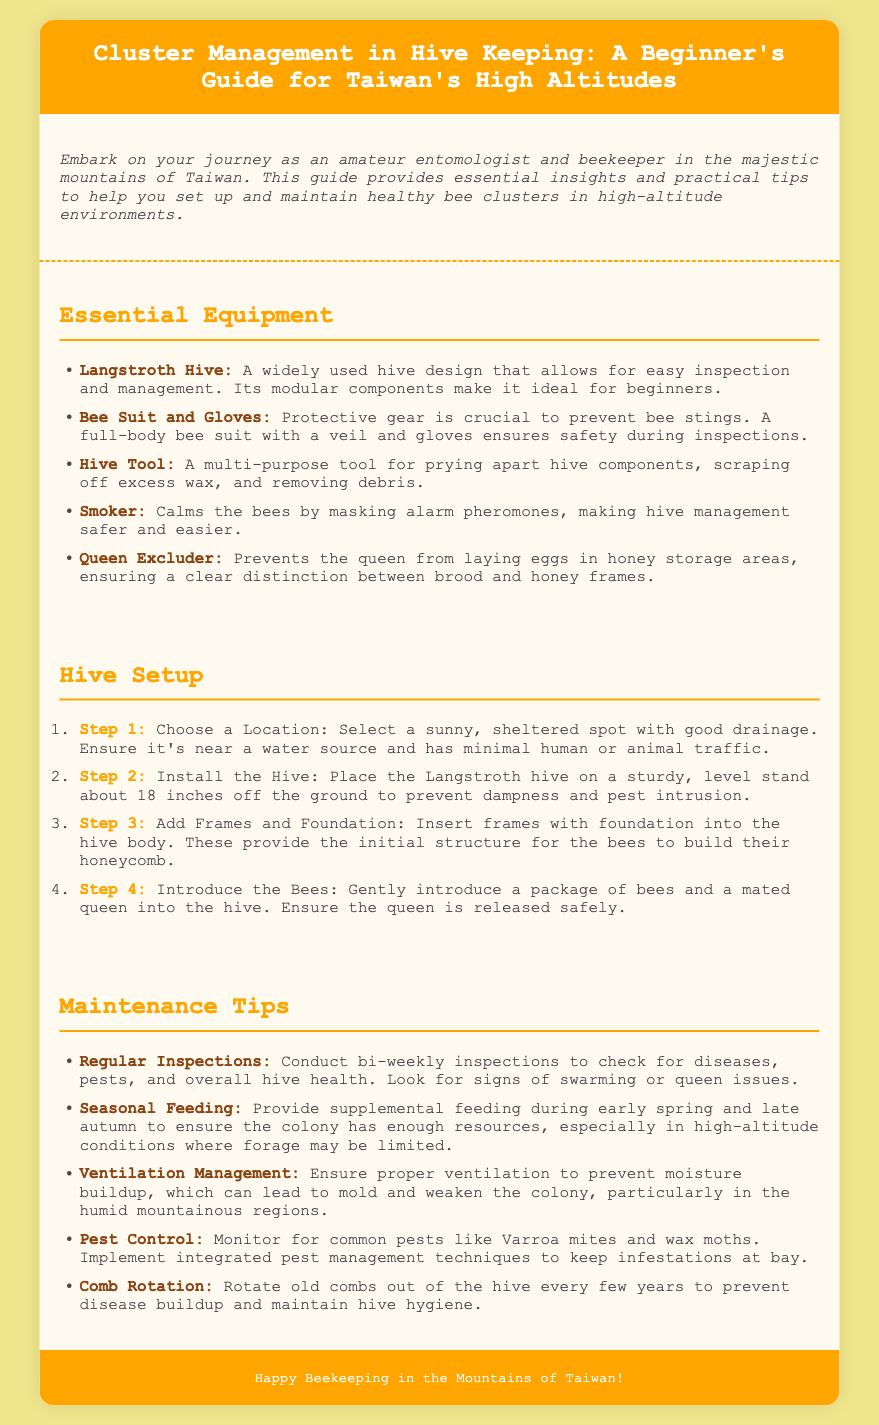What is the main purpose of this guide? The guide provides essential insights and practical tips for beginner beekeepers in Taiwan's mountains.
Answer: essential insights and practical tips for beginner beekeepers What type of hive is mentioned in the document? The document specifies the Langstroth Hive as a widely used design.
Answer: Langstroth Hive How many maintenance tips are listed in the document? The document lists five maintenance tips for managing bee colonies.
Answer: five What is the first step in the hive setup? The first step involves selecting a sunny, sheltered location with good drainage.
Answer: Choose a Location What should you wear during hive inspections? Protective gear, including a full-body bee suit with a veil and gloves, is recommended.
Answer: Bee Suit and Gloves What is the purpose of a smoker? The smoker is used to calm the bees by masking alarm pheromones.
Answer: Calms the bees How often should regular inspections be conducted? The document recommends conducting inspections bi-weekly.
Answer: bi-weekly What should be monitored to prevent infestations? Common pests like Varroa mites and wax moths should be monitored.
Answer: Varroa mites and wax moths 